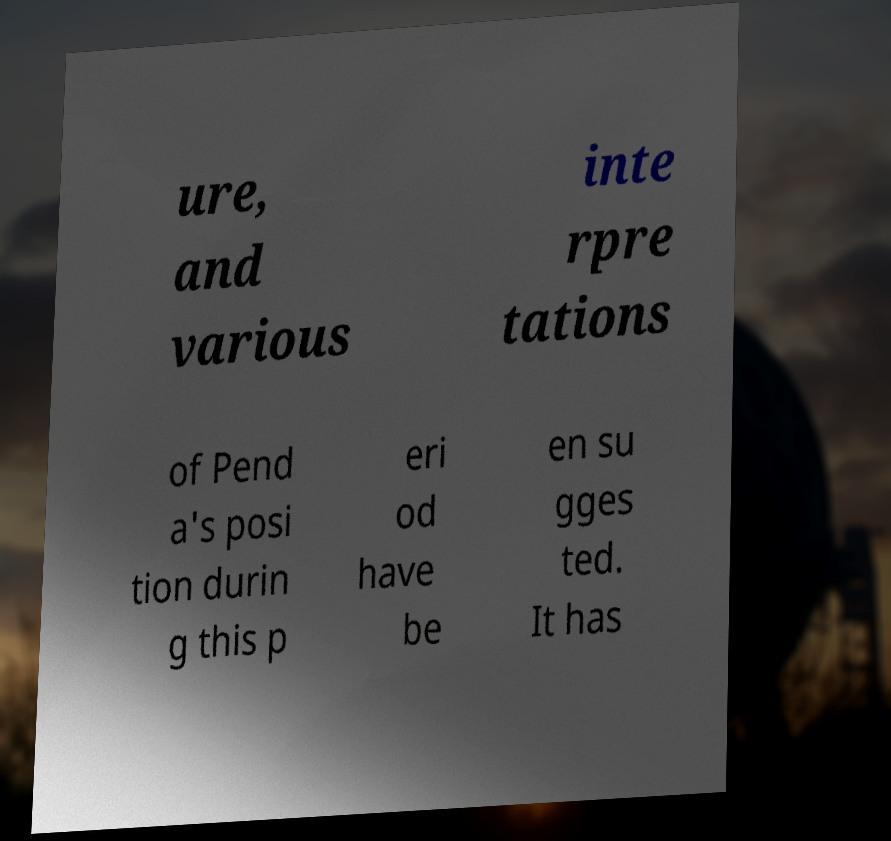Could you extract and type out the text from this image? ure, and various inte rpre tations of Pend a's posi tion durin g this p eri od have be en su gges ted. It has 